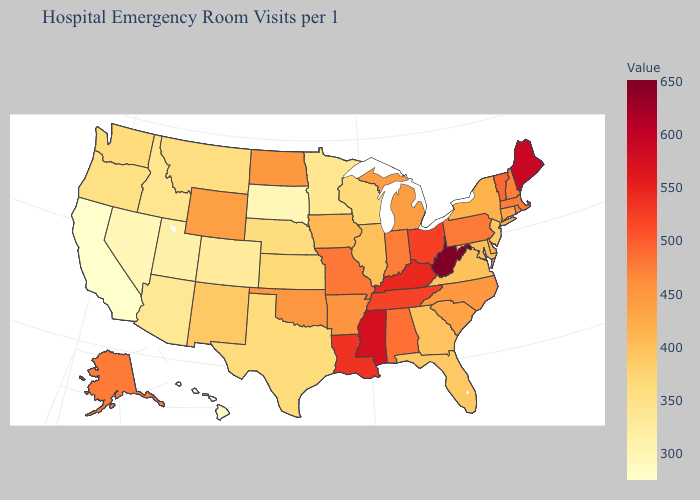Does West Virginia have the highest value in the USA?
Write a very short answer. Yes. Which states have the lowest value in the USA?
Concise answer only. California. Among the states that border Arizona , does California have the lowest value?
Give a very brief answer. Yes. Among the states that border Utah , which have the lowest value?
Short answer required. Nevada. Is the legend a continuous bar?
Be succinct. Yes. 